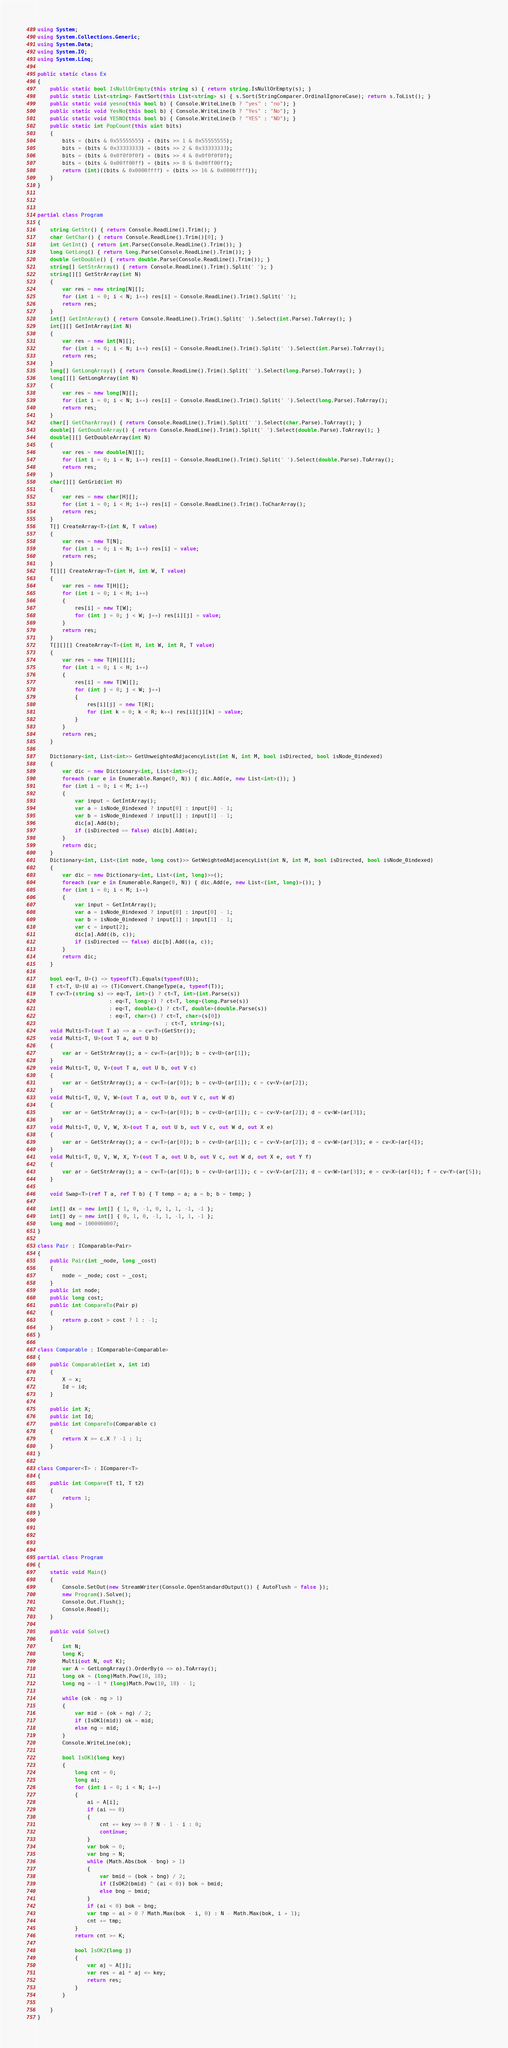Convert code to text. <code><loc_0><loc_0><loc_500><loc_500><_C#_>using System;
using System.Collections.Generic;
using System.Data;
using System.IO;
using System.Linq;

public static class Ex
{
    public static bool IsNullOrEmpty(this string s) { return string.IsNullOrEmpty(s); }
    public static List<string> FastSort(this List<string> s) { s.Sort(StringComparer.OrdinalIgnoreCase); return s.ToList(); }
    public static void yesno(this bool b) { Console.WriteLine(b ? "yes" : "no"); }
    public static void YesNo(this bool b) { Console.WriteLine(b ? "Yes" : "No"); }
    public static void YESNO(this bool b) { Console.WriteLine(b ? "YES" : "NO"); }
    public static int PopCount(this uint bits)
    {
        bits = (bits & 0x55555555) + (bits >> 1 & 0x55555555);
        bits = (bits & 0x33333333) + (bits >> 2 & 0x33333333);
        bits = (bits & 0x0f0f0f0f) + (bits >> 4 & 0x0f0f0f0f);
        bits = (bits & 0x00ff00ff) + (bits >> 8 & 0x00ff00ff);
        return (int)((bits & 0x0000ffff) + (bits >> 16 & 0x0000ffff));
    }
}



partial class Program
{
    string GetStr() { return Console.ReadLine().Trim(); }
    char GetChar() { return Console.ReadLine().Trim()[0]; }
    int GetInt() { return int.Parse(Console.ReadLine().Trim()); }
    long GetLong() { return long.Parse(Console.ReadLine().Trim()); }
    double GetDouble() { return double.Parse(Console.ReadLine().Trim()); }
    string[] GetStrArray() { return Console.ReadLine().Trim().Split(' '); }
    string[][] GetStrArray(int N)
    {
        var res = new string[N][];
        for (int i = 0; i < N; i++) res[i] = Console.ReadLine().Trim().Split(' ');
        return res;
    }
    int[] GetIntArray() { return Console.ReadLine().Trim().Split(' ').Select(int.Parse).ToArray(); }
    int[][] GetIntArray(int N)
    {
        var res = new int[N][];
        for (int i = 0; i < N; i++) res[i] = Console.ReadLine().Trim().Split(' ').Select(int.Parse).ToArray();
        return res;
    }
    long[] GetLongArray() { return Console.ReadLine().Trim().Split(' ').Select(long.Parse).ToArray(); }
    long[][] GetLongArray(int N)
    {
        var res = new long[N][];
        for (int i = 0; i < N; i++) res[i] = Console.ReadLine().Trim().Split(' ').Select(long.Parse).ToArray();
        return res;
    }
    char[] GetCharArray() { return Console.ReadLine().Trim().Split(' ').Select(char.Parse).ToArray(); }
    double[] GetDoubleArray() { return Console.ReadLine().Trim().Split(' ').Select(double.Parse).ToArray(); }
    double[][] GetDoubleArray(int N)
    {
        var res = new double[N][];
        for (int i = 0; i < N; i++) res[i] = Console.ReadLine().Trim().Split(' ').Select(double.Parse).ToArray();
        return res;
    }
    char[][] GetGrid(int H)
    {
        var res = new char[H][];
        for (int i = 0; i < H; i++) res[i] = Console.ReadLine().Trim().ToCharArray();
        return res;
    }
    T[] CreateArray<T>(int N, T value)
    {
        var res = new T[N];
        for (int i = 0; i < N; i++) res[i] = value;
        return res;
    }
    T[][] CreateArray<T>(int H, int W, T value)
    {
        var res = new T[H][];
        for (int i = 0; i < H; i++)
        {
            res[i] = new T[W];
            for (int j = 0; j < W; j++) res[i][j] = value;
        }
        return res;
    }
    T[][][] CreateArray<T>(int H, int W, int R, T value)
    {
        var res = new T[H][][];
        for (int i = 0; i < H; i++)
        {
            res[i] = new T[W][];
            for (int j = 0; j < W; j++)
            {
                res[i][j] = new T[R];
                for (int k = 0; k < R; k++) res[i][j][k] = value;
            }
        }
        return res;
    }

    Dictionary<int, List<int>> GetUnweightedAdjacencyList(int N, int M, bool isDirected, bool isNode_0indexed)
    {
        var dic = new Dictionary<int, List<int>>();
        foreach (var e in Enumerable.Range(0, N)) { dic.Add(e, new List<int>()); }
        for (int i = 0; i < M; i++)
        {
            var input = GetIntArray();
            var a = isNode_0indexed ? input[0] : input[0] - 1;
            var b = isNode_0indexed ? input[1] : input[1] - 1;
            dic[a].Add(b);
            if (isDirected == false) dic[b].Add(a);
        }
        return dic;
    }
    Dictionary<int, List<(int node, long cost)>> GetWeightedAdjacencyList(int N, int M, bool isDirected, bool isNode_0indexed)
    {
        var dic = new Dictionary<int, List<(int, long)>>();
        foreach (var e in Enumerable.Range(0, N)) { dic.Add(e, new List<(int, long)>()); }
        for (int i = 0; i < M; i++)
        {
            var input = GetIntArray();
            var a = isNode_0indexed ? input[0] : input[0] - 1;
            var b = isNode_0indexed ? input[1] : input[1] - 1;
            var c = input[2];
            dic[a].Add((b, c));
            if (isDirected == false) dic[b].Add((a, c));
        }
        return dic;
    }

    bool eq<T, U>() => typeof(T).Equals(typeof(U));
    T ct<T, U>(U a) => (T)Convert.ChangeType(a, typeof(T));
    T cv<T>(string s) => eq<T, int>() ? ct<T, int>(int.Parse(s))
                       : eq<T, long>() ? ct<T, long>(long.Parse(s))
                       : eq<T, double>() ? ct<T, double>(double.Parse(s))
                       : eq<T, char>() ? ct<T, char>(s[0])
                                         : ct<T, string>(s);
    void Multi<T>(out T a) => a = cv<T>(GetStr());
    void Multi<T, U>(out T a, out U b)
    {
        var ar = GetStrArray(); a = cv<T>(ar[0]); b = cv<U>(ar[1]);
    }
    void Multi<T, U, V>(out T a, out U b, out V c)
    {
        var ar = GetStrArray(); a = cv<T>(ar[0]); b = cv<U>(ar[1]); c = cv<V>(ar[2]);
    }
    void Multi<T, U, V, W>(out T a, out U b, out V c, out W d)
    {
        var ar = GetStrArray(); a = cv<T>(ar[0]); b = cv<U>(ar[1]); c = cv<V>(ar[2]); d = cv<W>(ar[3]);
    }
    void Multi<T, U, V, W, X>(out T a, out U b, out V c, out W d, out X e)
    {
        var ar = GetStrArray(); a = cv<T>(ar[0]); b = cv<U>(ar[1]); c = cv<V>(ar[2]); d = cv<W>(ar[3]); e = cv<X>(ar[4]);
    }
    void Multi<T, U, V, W, X, Y>(out T a, out U b, out V c, out W d, out X e, out Y f)
    {
        var ar = GetStrArray(); a = cv<T>(ar[0]); b = cv<U>(ar[1]); c = cv<V>(ar[2]); d = cv<W>(ar[3]); e = cv<X>(ar[4]); f = cv<Y>(ar[5]);
    }

    void Swap<T>(ref T a, ref T b) { T temp = a; a = b; b = temp; }

    int[] dx = new int[] { 1, 0, -1, 0, 1, 1, -1, -1 };
    int[] dy = new int[] { 0, 1, 0, -1, 1, -1, 1, -1 };
    long mod = 1000000007;
}

class Pair : IComparable<Pair>
{
    public Pair(int _node, long _cost)
    {
        node = _node; cost = _cost;
    }
    public int node;
    public long cost;
    public int CompareTo(Pair p)
    {
        return p.cost > cost ? 1 : -1;
    }
}

class Comparable : IComparable<Comparable>
{
    public Comparable(int x, int id)
    {
        X = x;
        Id = id;
    }

    public int X;
    public int Id;
    public int CompareTo(Comparable c)
    {
        return X >= c.X ? -1 : 1;
    }
}

class Comparer<T> : IComparer<T>
{
    public int Compare(T t1, T t2)
    {
        return 1;
    }
}





partial class Program
{
    static void Main()
    {
        Console.SetOut(new StreamWriter(Console.OpenStandardOutput()) { AutoFlush = false });
        new Program().Solve();
        Console.Out.Flush();
        Console.Read();
    }

    public void Solve()
    {
        int N;
        long K;
        Multi(out N, out K);
        var A = GetLongArray().OrderBy(o => o).ToArray();
        long ok = (long)Math.Pow(10, 18);
        long ng = -1 * (long)Math.Pow(10, 18) - 1;

        while (ok - ng > 1)
        {
            var mid = (ok + ng) / 2;
            if (IsOK1(mid)) ok = mid;
            else ng = mid;
        }
        Console.WriteLine(ok);

        bool IsOK1(long key)
        {
            long cnt = 0;
            long ai;
            for (int i = 0; i < N; i++)
            {
                ai = A[i];
                if (ai == 0)
                {
                    cnt += key >= 0 ? N - 1 - i : 0;
                    continue;
                }
                var bok = 0;
                var bng = N;
                while (Math.Abs(bok - bng) > 1)
                {
                    var bmid = (bok + bng) / 2;
                    if (IsOK2(bmid) ^ (ai < 0)) bok = bmid;
                    else bng = bmid;
                }
                if (ai < 0) bok = bng;
                var tmp = ai > 0 ? Math.Max(bok - i, 0) : N - Math.Max(bok, i + 1);
                cnt += tmp;
            }
            return cnt >= K;

            bool IsOK2(long j)
            {
                var aj = A[j];
                var res = ai * aj <= key;
                return res;
            }
        }

    }
}
</code> 